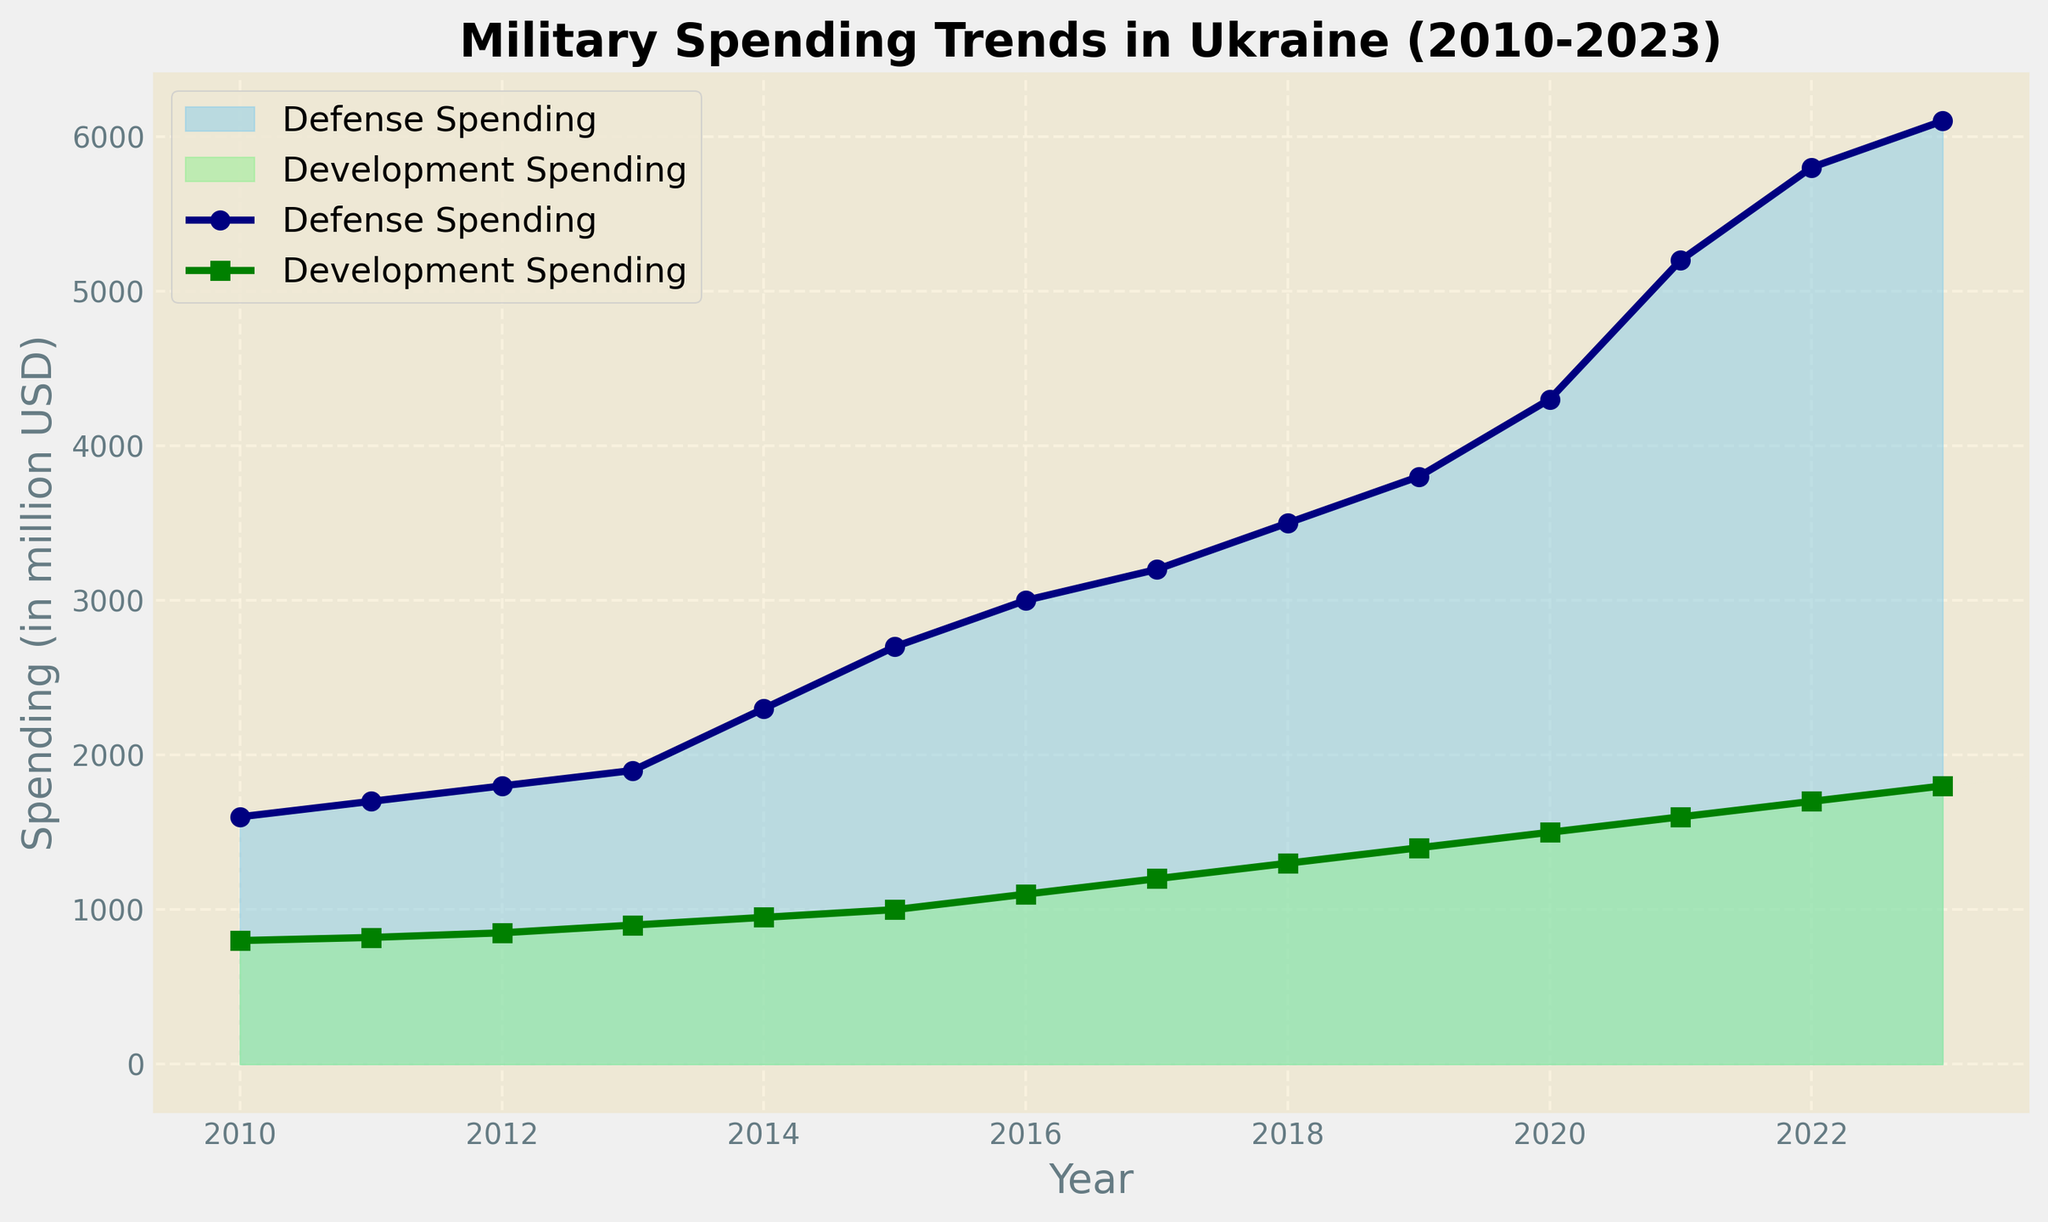What's the overall trend of defense spending from 2010 to 2023? From the chart, it is clear that defense spending in Ukraine has been increasing each year from 2010 to 2023. This is observed by the upward slope of the defense spending area marked by sky blue.
Answer: Increasing In which year did defense spending surpass development spending by the largest amount? To find this, observe the vertical distance between the defense and development spending lines. In 2023, defense spending is $6100 million, and development spending is $1800 million, resulting in the largest difference of $4300 million.
Answer: 2023 How does development spending in 2015 compare to that in 2010? In 2010, development spending was $800 million, and in 2015, it was $1000 million, which means there was an increase of $200 million.
Answer: Increased by $200 million What is the total spending (defense + development) in 2022? Defense spending in 2022 is $5800 million, and development spending is $1700 million. Summing them up: $5800 + $1700 = $7500 million.
Answer: $7500 million Which spending category (defense or development) had a more consistent annual increase throughout the years? Observing the shape and uniformity of the respective areas: Development spending, indicated by light green, shows a more steady and consistent increase, whereas the defense spending, marked by sky blue, shows more volatility and greater increases in some years.
Answer: Development spending What is the difference in spending between defense and development in 2020? Defense spending in 2020 is $4300 million, and development spending is $1500 million, so the difference is $4300 - $1500 = $2800 million.
Answer: $2800 million By how much did defense spending increase from 2011 to 2023? Defense spending in 2011 is $1700 million, and in 2023 it is $6100 million. The increase is $6100 - $1700 = $4400 million.
Answer: $4400 million Describe the visual difference between defense and development spending in terms of color and area representation. Defense spending is represented by a sky blue area and shows a larger and more rapidly increasing area over time. Development spending is depicted using a light green color, with a smaller and more steadily increasing area.
Answer: Sky blue for defense and light green for development 